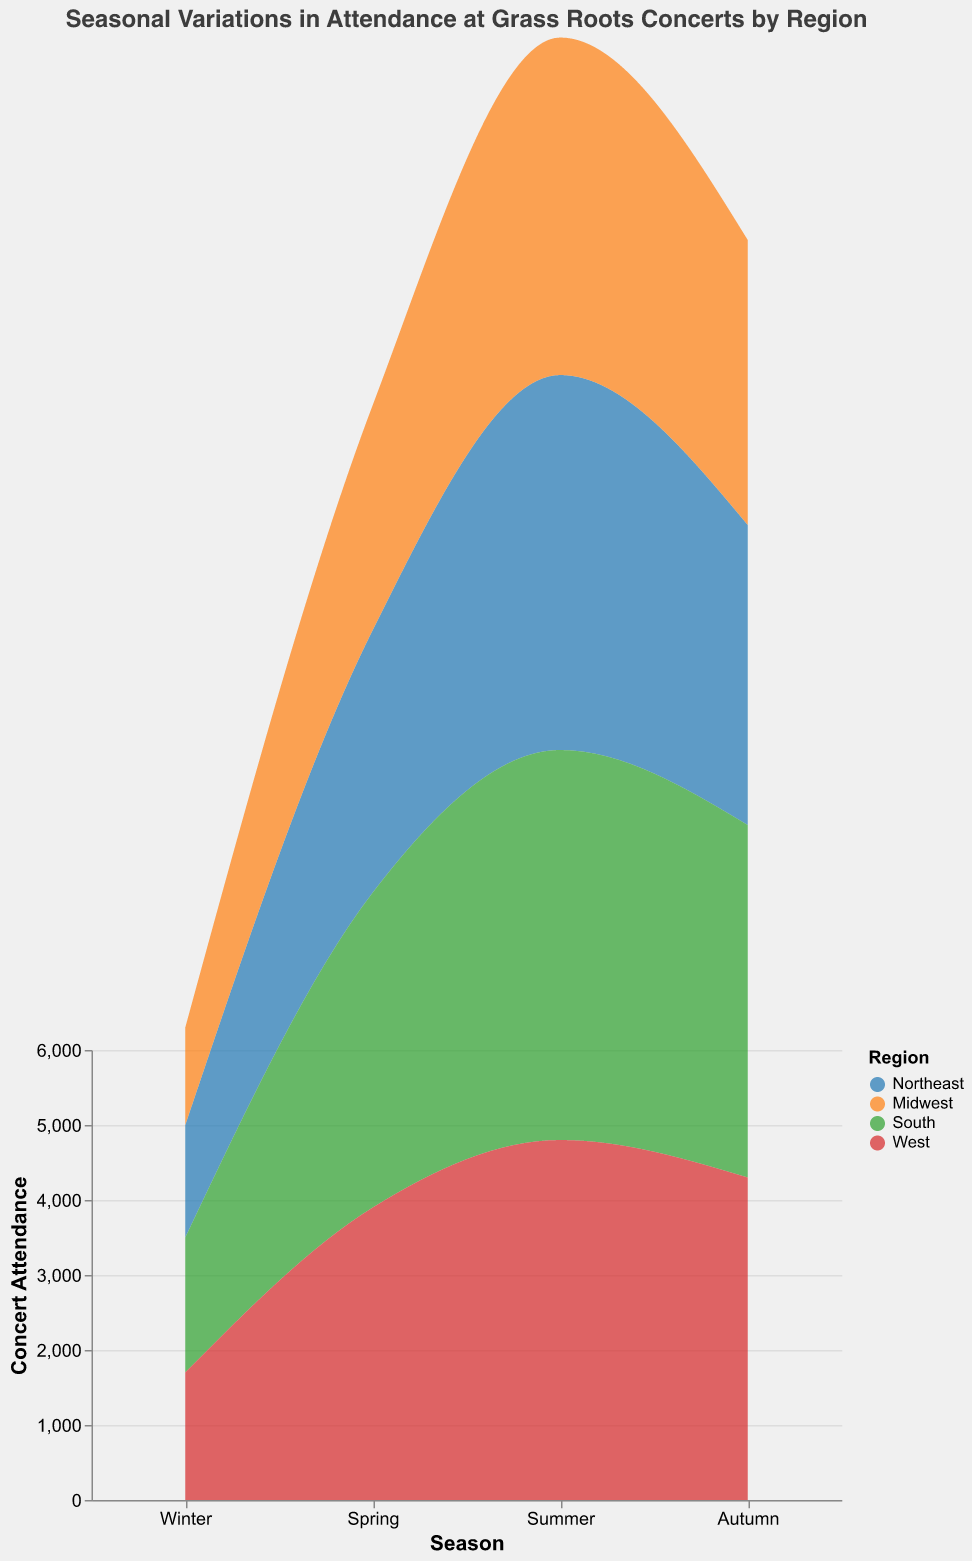What's the title of the chart? The title of the chart is text placed typically at the top of the figure, which states the main subject of the chart.
Answer: Seasonal Variations in Attendance at Grass Roots Concerts by Region What season has the highest concert attendance? To determine the season with the highest concert attendance, observe the plotted areas for each season and compare their heights (y-axis values). Summer has the highest attendance values across regions.
Answer: Summer Which region has the highest winter attendance? Check the height of the areas representing winter for each region, identifying the highest point. The South has the highest winter attendance.
Answer: South What is the total attendance for the Northeast region? Add up the attendance values for each season in the Northeast: 1500 (Winter) + 3500 (Spring) + 5000 (Summer) + 4000 (Autumn). This gives a total of 14,000.
Answer: 14,000 During which seasons is concert attendance lower in the Midwest compared to the South? Compare the areas representing Midwest and South region in each season and check the y-axis values. The Midwest has lower attendance in Winter, Spring, and Autumn compared to the South.
Answer: Winter, Spring, Autumn What's the difference in summer attendance between the West and Northeast regions? Subtract the summer attendance of the Northeast from the West. 4800 (West) - 5000 (Northeast) = -200.
Answer: -200 Which region shows the most consistent concert attendance across seasons? Look for the region where the variation in the height of areas across seasons is minimal. The Midwest shows the most consistent attendance, with values relatively close to each other across all seasons.
Answer: Midwest In which season does the West region have the lowest attendance? Observe the heights of the areas for each season in the West region and identify the smallest. Winter has the lowest attendance for the West.
Answer: Winter How does the attendance in Spring compare between the South and the West regions? Compare the heights of the areas for Spring in both South and West on the y-axis. The South has higher attendance than the West in Spring (4200 vs. 3900).
Answer: South is higher Which regions have an autumn attendance greater than 4000? Check the y-axis value for autumn in each region and see which are above 4000. South and West regions have an autumn attendance greater than 4000.
Answer: South, West 